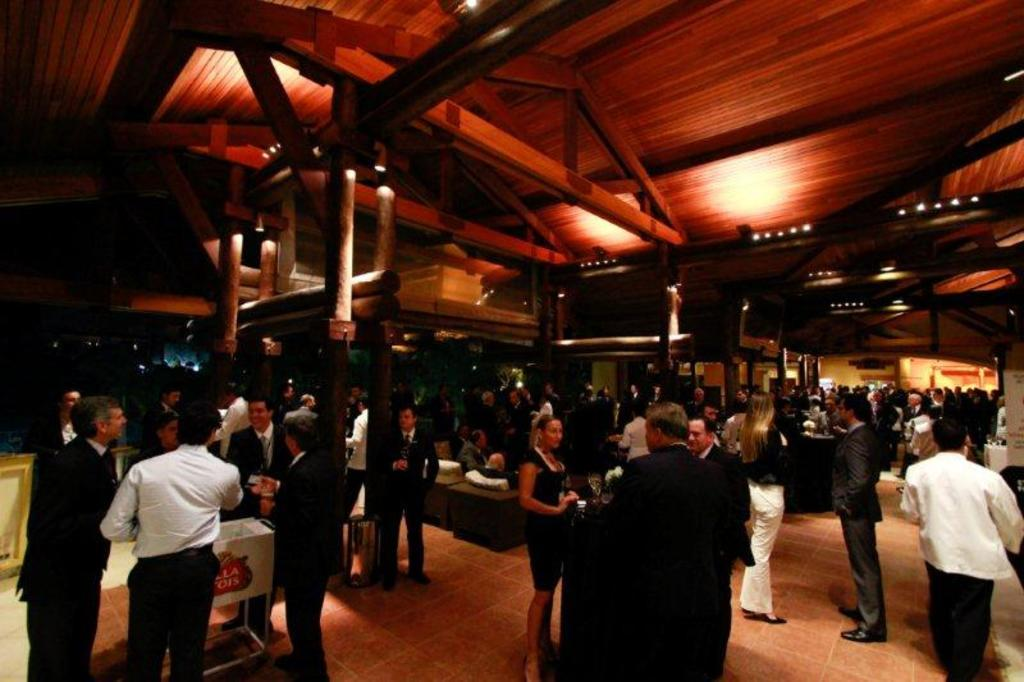How many people can be seen in the image? There are many people in the image. What type of architectural feature is present in the image? There are wooden pillars in the image. What can be found on the ceiling in the image? There are lights on the ceiling. What material is the ceiling made of? The ceiling is wooden. Can you describe any other items visible in the image? There are other items in the image, but their specific details are not mentioned in the provided facts. What type of fruit is being served at the event in the image? There is no mention of an event or fruit in the provided facts, so we cannot answer this question based on the image. 